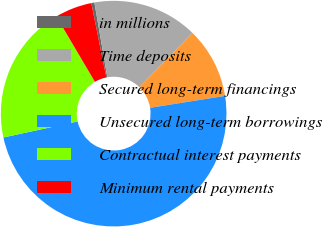Convert chart. <chart><loc_0><loc_0><loc_500><loc_500><pie_chart><fcel>in millions<fcel>Time deposits<fcel>Secured long-term financings<fcel>Unsecured long-term borrowings<fcel>Contractual interest payments<fcel>Minimum rental payments<nl><fcel>0.44%<fcel>15.04%<fcel>10.18%<fcel>49.12%<fcel>19.91%<fcel>5.31%<nl></chart> 